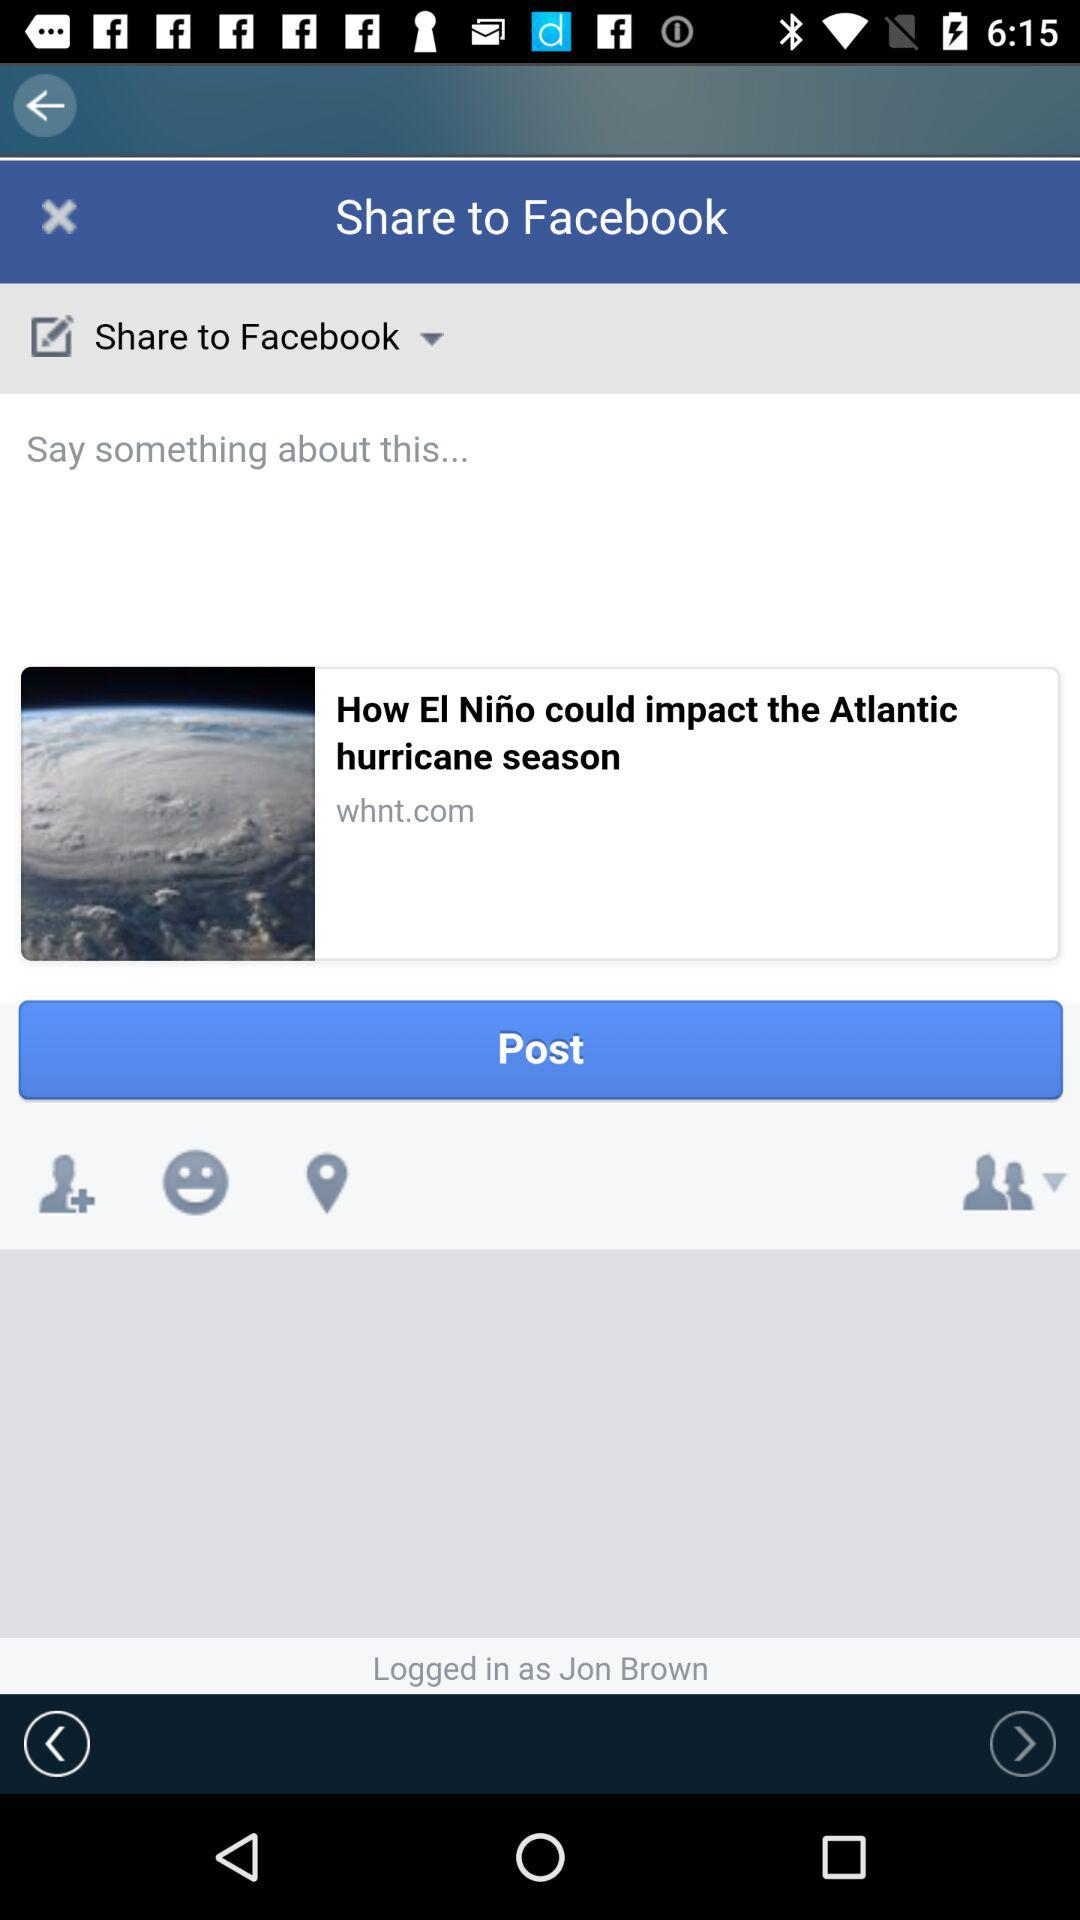Where is the user located?
When the provided information is insufficient, respond with <no answer>. <no answer> 